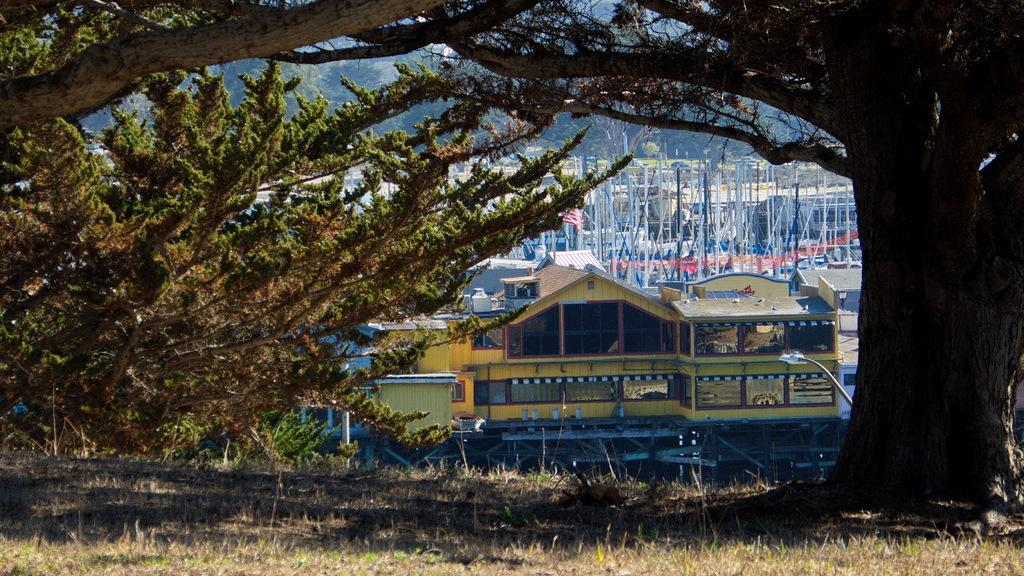What type of structures can be seen in the image? There are houses in the image. What is the color and texture of the ground in the image? There is green grass visible in the image. What type of vegetation is present in the image? There are trees in the image. Can you describe the breakfast being served in the image? There is no breakfast visible in the image; it only features houses, green grass, and trees. How many deer can be seen in the image? There are no deer present in the image. 